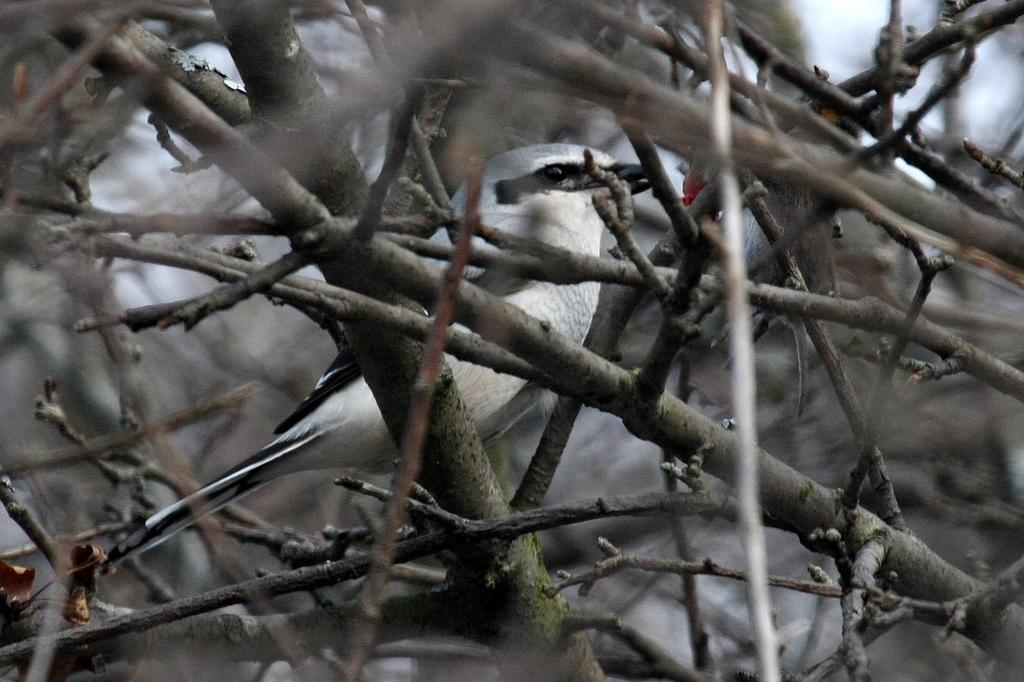What type of animal can be seen in the image? There is a bird in the image. Are there any other animals present besides the bird? Yes, there are animals in the image. What can be seen supporting the animals in the image? There are stems in the image. What type of plant material can be seen in the image? There are dry leaves in the image. What type of cushion is being used by the bird in the image? There is no cushion present in the image; the bird is perched on stems and dry leaves. 